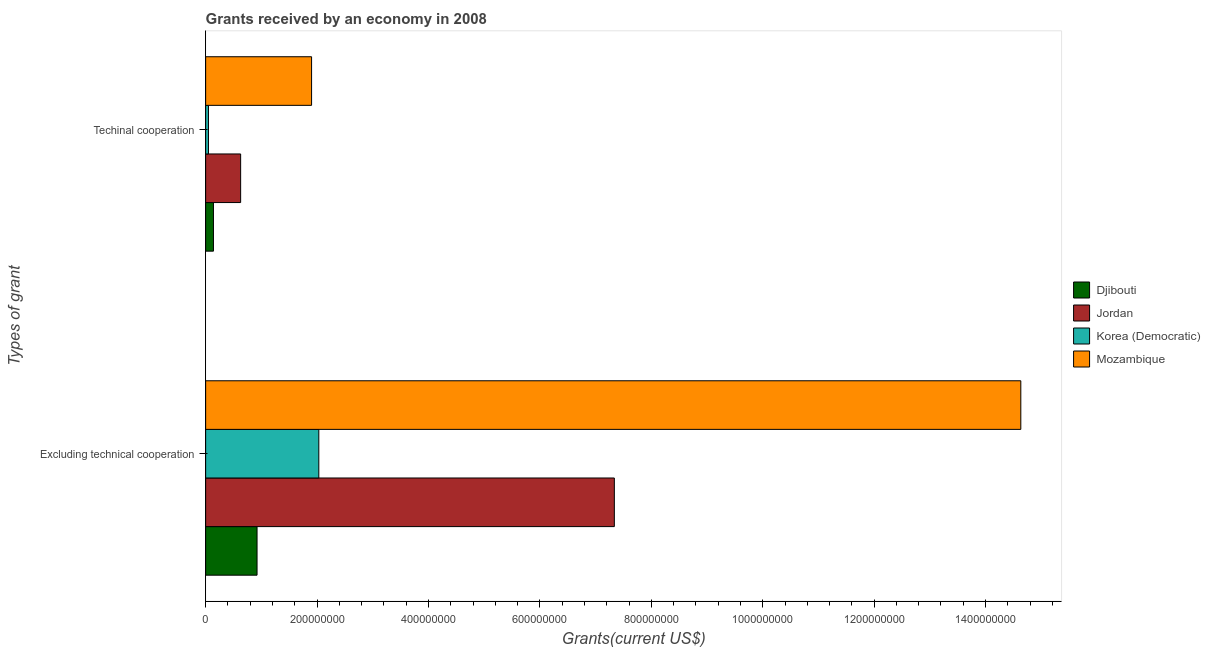How many groups of bars are there?
Offer a very short reply. 2. Are the number of bars on each tick of the Y-axis equal?
Your answer should be compact. Yes. What is the label of the 1st group of bars from the top?
Give a very brief answer. Techinal cooperation. What is the amount of grants received(including technical cooperation) in Djibouti?
Your answer should be very brief. 1.40e+07. Across all countries, what is the maximum amount of grants received(including technical cooperation)?
Your answer should be very brief. 1.90e+08. Across all countries, what is the minimum amount of grants received(excluding technical cooperation)?
Ensure brevity in your answer.  9.23e+07. In which country was the amount of grants received(excluding technical cooperation) maximum?
Make the answer very short. Mozambique. In which country was the amount of grants received(excluding technical cooperation) minimum?
Offer a very short reply. Djibouti. What is the total amount of grants received(excluding technical cooperation) in the graph?
Your response must be concise. 2.49e+09. What is the difference between the amount of grants received(excluding technical cooperation) in Jordan and that in Korea (Democratic)?
Provide a short and direct response. 5.30e+08. What is the difference between the amount of grants received(excluding technical cooperation) in Djibouti and the amount of grants received(including technical cooperation) in Jordan?
Your answer should be very brief. 2.94e+07. What is the average amount of grants received(including technical cooperation) per country?
Make the answer very short. 6.80e+07. What is the difference between the amount of grants received(including technical cooperation) and amount of grants received(excluding technical cooperation) in Korea (Democratic)?
Provide a succinct answer. -1.98e+08. In how many countries, is the amount of grants received(including technical cooperation) greater than 1320000000 US$?
Ensure brevity in your answer.  0. What is the ratio of the amount of grants received(including technical cooperation) in Korea (Democratic) to that in Jordan?
Your answer should be very brief. 0.08. Is the amount of grants received(excluding technical cooperation) in Korea (Democratic) less than that in Mozambique?
Give a very brief answer. Yes. What does the 3rd bar from the top in Excluding technical cooperation represents?
Offer a very short reply. Jordan. What does the 4th bar from the bottom in Excluding technical cooperation represents?
Make the answer very short. Mozambique. What is the difference between two consecutive major ticks on the X-axis?
Make the answer very short. 2.00e+08. Does the graph contain any zero values?
Your answer should be very brief. No. Does the graph contain grids?
Provide a succinct answer. No. Where does the legend appear in the graph?
Provide a succinct answer. Center right. What is the title of the graph?
Keep it short and to the point. Grants received by an economy in 2008. Does "Switzerland" appear as one of the legend labels in the graph?
Give a very brief answer. No. What is the label or title of the X-axis?
Ensure brevity in your answer.  Grants(current US$). What is the label or title of the Y-axis?
Your response must be concise. Types of grant. What is the Grants(current US$) of Djibouti in Excluding technical cooperation?
Give a very brief answer. 9.23e+07. What is the Grants(current US$) in Jordan in Excluding technical cooperation?
Make the answer very short. 7.34e+08. What is the Grants(current US$) of Korea (Democratic) in Excluding technical cooperation?
Give a very brief answer. 2.03e+08. What is the Grants(current US$) in Mozambique in Excluding technical cooperation?
Give a very brief answer. 1.46e+09. What is the Grants(current US$) in Djibouti in Techinal cooperation?
Keep it short and to the point. 1.40e+07. What is the Grants(current US$) in Jordan in Techinal cooperation?
Ensure brevity in your answer.  6.28e+07. What is the Grants(current US$) of Korea (Democratic) in Techinal cooperation?
Your answer should be very brief. 5.09e+06. What is the Grants(current US$) in Mozambique in Techinal cooperation?
Provide a succinct answer. 1.90e+08. Across all Types of grant, what is the maximum Grants(current US$) of Djibouti?
Offer a very short reply. 9.23e+07. Across all Types of grant, what is the maximum Grants(current US$) of Jordan?
Provide a succinct answer. 7.34e+08. Across all Types of grant, what is the maximum Grants(current US$) of Korea (Democratic)?
Your response must be concise. 2.03e+08. Across all Types of grant, what is the maximum Grants(current US$) of Mozambique?
Your answer should be very brief. 1.46e+09. Across all Types of grant, what is the minimum Grants(current US$) in Djibouti?
Ensure brevity in your answer.  1.40e+07. Across all Types of grant, what is the minimum Grants(current US$) of Jordan?
Offer a terse response. 6.28e+07. Across all Types of grant, what is the minimum Grants(current US$) of Korea (Democratic)?
Keep it short and to the point. 5.09e+06. Across all Types of grant, what is the minimum Grants(current US$) of Mozambique?
Offer a terse response. 1.90e+08. What is the total Grants(current US$) of Djibouti in the graph?
Your answer should be compact. 1.06e+08. What is the total Grants(current US$) in Jordan in the graph?
Give a very brief answer. 7.96e+08. What is the total Grants(current US$) of Korea (Democratic) in the graph?
Your response must be concise. 2.08e+08. What is the total Grants(current US$) in Mozambique in the graph?
Give a very brief answer. 1.65e+09. What is the difference between the Grants(current US$) of Djibouti in Excluding technical cooperation and that in Techinal cooperation?
Your answer should be compact. 7.83e+07. What is the difference between the Grants(current US$) of Jordan in Excluding technical cooperation and that in Techinal cooperation?
Ensure brevity in your answer.  6.71e+08. What is the difference between the Grants(current US$) in Korea (Democratic) in Excluding technical cooperation and that in Techinal cooperation?
Ensure brevity in your answer.  1.98e+08. What is the difference between the Grants(current US$) in Mozambique in Excluding technical cooperation and that in Techinal cooperation?
Provide a succinct answer. 1.27e+09. What is the difference between the Grants(current US$) of Djibouti in Excluding technical cooperation and the Grants(current US$) of Jordan in Techinal cooperation?
Your answer should be very brief. 2.94e+07. What is the difference between the Grants(current US$) in Djibouti in Excluding technical cooperation and the Grants(current US$) in Korea (Democratic) in Techinal cooperation?
Your answer should be compact. 8.72e+07. What is the difference between the Grants(current US$) in Djibouti in Excluding technical cooperation and the Grants(current US$) in Mozambique in Techinal cooperation?
Offer a very short reply. -9.79e+07. What is the difference between the Grants(current US$) in Jordan in Excluding technical cooperation and the Grants(current US$) in Korea (Democratic) in Techinal cooperation?
Offer a very short reply. 7.29e+08. What is the difference between the Grants(current US$) of Jordan in Excluding technical cooperation and the Grants(current US$) of Mozambique in Techinal cooperation?
Ensure brevity in your answer.  5.43e+08. What is the difference between the Grants(current US$) in Korea (Democratic) in Excluding technical cooperation and the Grants(current US$) in Mozambique in Techinal cooperation?
Provide a succinct answer. 1.30e+07. What is the average Grants(current US$) in Djibouti per Types of grant?
Give a very brief answer. 5.32e+07. What is the average Grants(current US$) in Jordan per Types of grant?
Provide a succinct answer. 3.98e+08. What is the average Grants(current US$) of Korea (Democratic) per Types of grant?
Offer a very short reply. 1.04e+08. What is the average Grants(current US$) in Mozambique per Types of grant?
Make the answer very short. 8.27e+08. What is the difference between the Grants(current US$) of Djibouti and Grants(current US$) of Jordan in Excluding technical cooperation?
Keep it short and to the point. -6.41e+08. What is the difference between the Grants(current US$) of Djibouti and Grants(current US$) of Korea (Democratic) in Excluding technical cooperation?
Your response must be concise. -1.11e+08. What is the difference between the Grants(current US$) of Djibouti and Grants(current US$) of Mozambique in Excluding technical cooperation?
Make the answer very short. -1.37e+09. What is the difference between the Grants(current US$) in Jordan and Grants(current US$) in Korea (Democratic) in Excluding technical cooperation?
Provide a succinct answer. 5.30e+08. What is the difference between the Grants(current US$) of Jordan and Grants(current US$) of Mozambique in Excluding technical cooperation?
Keep it short and to the point. -7.30e+08. What is the difference between the Grants(current US$) of Korea (Democratic) and Grants(current US$) of Mozambique in Excluding technical cooperation?
Provide a succinct answer. -1.26e+09. What is the difference between the Grants(current US$) of Djibouti and Grants(current US$) of Jordan in Techinal cooperation?
Offer a terse response. -4.88e+07. What is the difference between the Grants(current US$) in Djibouti and Grants(current US$) in Korea (Democratic) in Techinal cooperation?
Give a very brief answer. 8.94e+06. What is the difference between the Grants(current US$) in Djibouti and Grants(current US$) in Mozambique in Techinal cooperation?
Your response must be concise. -1.76e+08. What is the difference between the Grants(current US$) of Jordan and Grants(current US$) of Korea (Democratic) in Techinal cooperation?
Give a very brief answer. 5.78e+07. What is the difference between the Grants(current US$) of Jordan and Grants(current US$) of Mozambique in Techinal cooperation?
Your answer should be compact. -1.27e+08. What is the difference between the Grants(current US$) in Korea (Democratic) and Grants(current US$) in Mozambique in Techinal cooperation?
Your answer should be very brief. -1.85e+08. What is the ratio of the Grants(current US$) in Djibouti in Excluding technical cooperation to that in Techinal cooperation?
Ensure brevity in your answer.  6.58. What is the ratio of the Grants(current US$) in Jordan in Excluding technical cooperation to that in Techinal cooperation?
Your answer should be very brief. 11.67. What is the ratio of the Grants(current US$) of Korea (Democratic) in Excluding technical cooperation to that in Techinal cooperation?
Offer a terse response. 39.92. What is the ratio of the Grants(current US$) in Mozambique in Excluding technical cooperation to that in Techinal cooperation?
Provide a short and direct response. 7.69. What is the difference between the highest and the second highest Grants(current US$) in Djibouti?
Ensure brevity in your answer.  7.83e+07. What is the difference between the highest and the second highest Grants(current US$) of Jordan?
Your answer should be compact. 6.71e+08. What is the difference between the highest and the second highest Grants(current US$) of Korea (Democratic)?
Offer a very short reply. 1.98e+08. What is the difference between the highest and the second highest Grants(current US$) in Mozambique?
Your response must be concise. 1.27e+09. What is the difference between the highest and the lowest Grants(current US$) in Djibouti?
Ensure brevity in your answer.  7.83e+07. What is the difference between the highest and the lowest Grants(current US$) in Jordan?
Ensure brevity in your answer.  6.71e+08. What is the difference between the highest and the lowest Grants(current US$) of Korea (Democratic)?
Make the answer very short. 1.98e+08. What is the difference between the highest and the lowest Grants(current US$) of Mozambique?
Make the answer very short. 1.27e+09. 